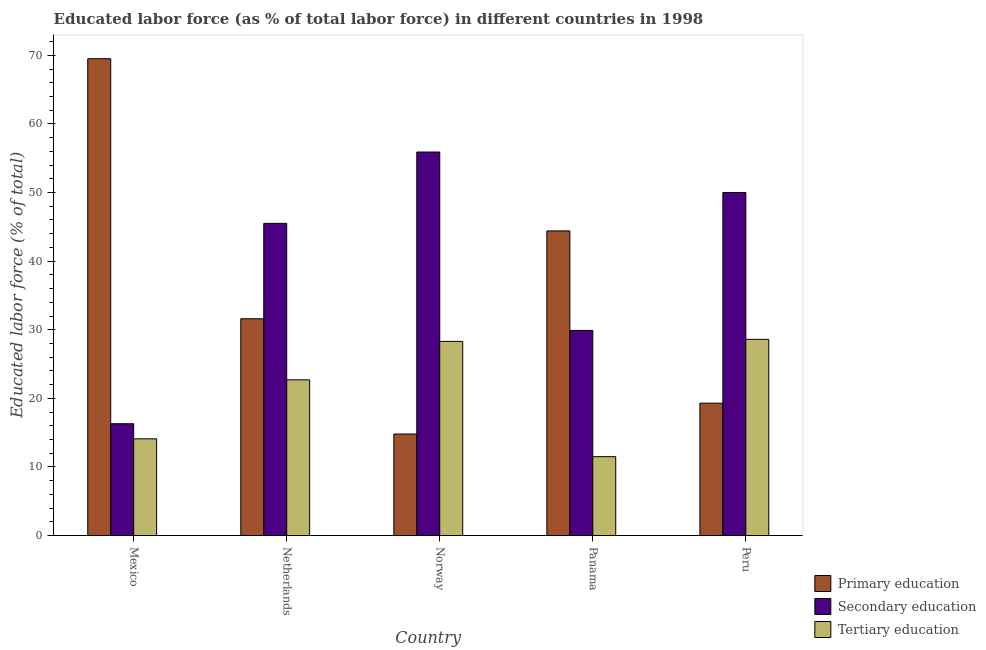How many different coloured bars are there?
Make the answer very short. 3. How many groups of bars are there?
Make the answer very short. 5. Are the number of bars per tick equal to the number of legend labels?
Your answer should be compact. Yes. What is the label of the 5th group of bars from the left?
Ensure brevity in your answer.  Peru. What is the percentage of labor force who received secondary education in Norway?
Ensure brevity in your answer.  55.9. Across all countries, what is the maximum percentage of labor force who received tertiary education?
Ensure brevity in your answer.  28.6. Across all countries, what is the minimum percentage of labor force who received primary education?
Give a very brief answer. 14.8. In which country was the percentage of labor force who received primary education minimum?
Keep it short and to the point. Norway. What is the total percentage of labor force who received tertiary education in the graph?
Give a very brief answer. 105.2. What is the difference between the percentage of labor force who received secondary education in Norway and that in Panama?
Make the answer very short. 26. What is the difference between the percentage of labor force who received secondary education in Peru and the percentage of labor force who received tertiary education in Netherlands?
Provide a short and direct response. 27.3. What is the average percentage of labor force who received secondary education per country?
Provide a succinct answer. 39.52. What is the difference between the percentage of labor force who received primary education and percentage of labor force who received tertiary education in Panama?
Keep it short and to the point. 32.9. In how many countries, is the percentage of labor force who received tertiary education greater than 20 %?
Your response must be concise. 3. What is the ratio of the percentage of labor force who received primary education in Norway to that in Peru?
Your answer should be very brief. 0.77. Is the difference between the percentage of labor force who received primary education in Norway and Peru greater than the difference between the percentage of labor force who received tertiary education in Norway and Peru?
Provide a short and direct response. No. What is the difference between the highest and the second highest percentage of labor force who received primary education?
Offer a terse response. 25.1. What is the difference between the highest and the lowest percentage of labor force who received secondary education?
Offer a terse response. 39.6. In how many countries, is the percentage of labor force who received tertiary education greater than the average percentage of labor force who received tertiary education taken over all countries?
Offer a terse response. 3. What does the 3rd bar from the left in Netherlands represents?
Offer a terse response. Tertiary education. What does the 3rd bar from the right in Norway represents?
Make the answer very short. Primary education. How many bars are there?
Your answer should be compact. 15. How many countries are there in the graph?
Your answer should be very brief. 5. What is the difference between two consecutive major ticks on the Y-axis?
Provide a short and direct response. 10. Does the graph contain grids?
Offer a terse response. No. Where does the legend appear in the graph?
Offer a terse response. Bottom right. What is the title of the graph?
Your answer should be very brief. Educated labor force (as % of total labor force) in different countries in 1998. Does "Food" appear as one of the legend labels in the graph?
Offer a very short reply. No. What is the label or title of the Y-axis?
Your answer should be compact. Educated labor force (% of total). What is the Educated labor force (% of total) in Primary education in Mexico?
Keep it short and to the point. 69.5. What is the Educated labor force (% of total) in Secondary education in Mexico?
Give a very brief answer. 16.3. What is the Educated labor force (% of total) of Tertiary education in Mexico?
Give a very brief answer. 14.1. What is the Educated labor force (% of total) in Primary education in Netherlands?
Your response must be concise. 31.6. What is the Educated labor force (% of total) in Secondary education in Netherlands?
Ensure brevity in your answer.  45.5. What is the Educated labor force (% of total) in Tertiary education in Netherlands?
Keep it short and to the point. 22.7. What is the Educated labor force (% of total) of Primary education in Norway?
Your answer should be very brief. 14.8. What is the Educated labor force (% of total) of Secondary education in Norway?
Your response must be concise. 55.9. What is the Educated labor force (% of total) of Tertiary education in Norway?
Make the answer very short. 28.3. What is the Educated labor force (% of total) in Primary education in Panama?
Your answer should be very brief. 44.4. What is the Educated labor force (% of total) of Secondary education in Panama?
Offer a terse response. 29.9. What is the Educated labor force (% of total) in Primary education in Peru?
Your answer should be very brief. 19.3. What is the Educated labor force (% of total) in Tertiary education in Peru?
Give a very brief answer. 28.6. Across all countries, what is the maximum Educated labor force (% of total) of Primary education?
Offer a very short reply. 69.5. Across all countries, what is the maximum Educated labor force (% of total) in Secondary education?
Offer a terse response. 55.9. Across all countries, what is the maximum Educated labor force (% of total) in Tertiary education?
Give a very brief answer. 28.6. Across all countries, what is the minimum Educated labor force (% of total) of Primary education?
Keep it short and to the point. 14.8. Across all countries, what is the minimum Educated labor force (% of total) of Secondary education?
Make the answer very short. 16.3. What is the total Educated labor force (% of total) of Primary education in the graph?
Provide a short and direct response. 179.6. What is the total Educated labor force (% of total) in Secondary education in the graph?
Give a very brief answer. 197.6. What is the total Educated labor force (% of total) of Tertiary education in the graph?
Provide a short and direct response. 105.2. What is the difference between the Educated labor force (% of total) of Primary education in Mexico and that in Netherlands?
Provide a succinct answer. 37.9. What is the difference between the Educated labor force (% of total) in Secondary education in Mexico and that in Netherlands?
Offer a very short reply. -29.2. What is the difference between the Educated labor force (% of total) of Tertiary education in Mexico and that in Netherlands?
Provide a succinct answer. -8.6. What is the difference between the Educated labor force (% of total) in Primary education in Mexico and that in Norway?
Provide a short and direct response. 54.7. What is the difference between the Educated labor force (% of total) in Secondary education in Mexico and that in Norway?
Provide a succinct answer. -39.6. What is the difference between the Educated labor force (% of total) in Tertiary education in Mexico and that in Norway?
Provide a succinct answer. -14.2. What is the difference between the Educated labor force (% of total) of Primary education in Mexico and that in Panama?
Keep it short and to the point. 25.1. What is the difference between the Educated labor force (% of total) in Tertiary education in Mexico and that in Panama?
Offer a terse response. 2.6. What is the difference between the Educated labor force (% of total) of Primary education in Mexico and that in Peru?
Your answer should be very brief. 50.2. What is the difference between the Educated labor force (% of total) in Secondary education in Mexico and that in Peru?
Make the answer very short. -33.7. What is the difference between the Educated labor force (% of total) of Tertiary education in Mexico and that in Peru?
Provide a succinct answer. -14.5. What is the difference between the Educated labor force (% of total) of Primary education in Netherlands and that in Norway?
Provide a short and direct response. 16.8. What is the difference between the Educated labor force (% of total) of Secondary education in Netherlands and that in Norway?
Your answer should be very brief. -10.4. What is the difference between the Educated labor force (% of total) in Secondary education in Netherlands and that in Panama?
Provide a succinct answer. 15.6. What is the difference between the Educated labor force (% of total) in Primary education in Netherlands and that in Peru?
Your answer should be very brief. 12.3. What is the difference between the Educated labor force (% of total) in Secondary education in Netherlands and that in Peru?
Keep it short and to the point. -4.5. What is the difference between the Educated labor force (% of total) of Tertiary education in Netherlands and that in Peru?
Offer a terse response. -5.9. What is the difference between the Educated labor force (% of total) in Primary education in Norway and that in Panama?
Provide a succinct answer. -29.6. What is the difference between the Educated labor force (% of total) of Secondary education in Norway and that in Panama?
Your response must be concise. 26. What is the difference between the Educated labor force (% of total) in Primary education in Panama and that in Peru?
Offer a very short reply. 25.1. What is the difference between the Educated labor force (% of total) of Secondary education in Panama and that in Peru?
Make the answer very short. -20.1. What is the difference between the Educated labor force (% of total) in Tertiary education in Panama and that in Peru?
Give a very brief answer. -17.1. What is the difference between the Educated labor force (% of total) in Primary education in Mexico and the Educated labor force (% of total) in Secondary education in Netherlands?
Ensure brevity in your answer.  24. What is the difference between the Educated labor force (% of total) of Primary education in Mexico and the Educated labor force (% of total) of Tertiary education in Netherlands?
Ensure brevity in your answer.  46.8. What is the difference between the Educated labor force (% of total) of Primary education in Mexico and the Educated labor force (% of total) of Tertiary education in Norway?
Your answer should be compact. 41.2. What is the difference between the Educated labor force (% of total) in Primary education in Mexico and the Educated labor force (% of total) in Secondary education in Panama?
Your response must be concise. 39.6. What is the difference between the Educated labor force (% of total) of Primary education in Mexico and the Educated labor force (% of total) of Tertiary education in Panama?
Give a very brief answer. 58. What is the difference between the Educated labor force (% of total) in Primary education in Mexico and the Educated labor force (% of total) in Secondary education in Peru?
Your answer should be very brief. 19.5. What is the difference between the Educated labor force (% of total) in Primary education in Mexico and the Educated labor force (% of total) in Tertiary education in Peru?
Your response must be concise. 40.9. What is the difference between the Educated labor force (% of total) in Primary education in Netherlands and the Educated labor force (% of total) in Secondary education in Norway?
Ensure brevity in your answer.  -24.3. What is the difference between the Educated labor force (% of total) in Secondary education in Netherlands and the Educated labor force (% of total) in Tertiary education in Norway?
Provide a short and direct response. 17.2. What is the difference between the Educated labor force (% of total) of Primary education in Netherlands and the Educated labor force (% of total) of Secondary education in Panama?
Your answer should be very brief. 1.7. What is the difference between the Educated labor force (% of total) in Primary education in Netherlands and the Educated labor force (% of total) in Tertiary education in Panama?
Your response must be concise. 20.1. What is the difference between the Educated labor force (% of total) of Secondary education in Netherlands and the Educated labor force (% of total) of Tertiary education in Panama?
Your response must be concise. 34. What is the difference between the Educated labor force (% of total) in Primary education in Netherlands and the Educated labor force (% of total) in Secondary education in Peru?
Offer a terse response. -18.4. What is the difference between the Educated labor force (% of total) in Secondary education in Netherlands and the Educated labor force (% of total) in Tertiary education in Peru?
Offer a terse response. 16.9. What is the difference between the Educated labor force (% of total) of Primary education in Norway and the Educated labor force (% of total) of Secondary education in Panama?
Keep it short and to the point. -15.1. What is the difference between the Educated labor force (% of total) in Secondary education in Norway and the Educated labor force (% of total) in Tertiary education in Panama?
Offer a terse response. 44.4. What is the difference between the Educated labor force (% of total) of Primary education in Norway and the Educated labor force (% of total) of Secondary education in Peru?
Ensure brevity in your answer.  -35.2. What is the difference between the Educated labor force (% of total) in Secondary education in Norway and the Educated labor force (% of total) in Tertiary education in Peru?
Ensure brevity in your answer.  27.3. What is the difference between the Educated labor force (% of total) in Primary education in Panama and the Educated labor force (% of total) in Secondary education in Peru?
Offer a terse response. -5.6. What is the difference between the Educated labor force (% of total) in Primary education in Panama and the Educated labor force (% of total) in Tertiary education in Peru?
Your answer should be compact. 15.8. What is the difference between the Educated labor force (% of total) in Secondary education in Panama and the Educated labor force (% of total) in Tertiary education in Peru?
Make the answer very short. 1.3. What is the average Educated labor force (% of total) of Primary education per country?
Provide a succinct answer. 35.92. What is the average Educated labor force (% of total) in Secondary education per country?
Ensure brevity in your answer.  39.52. What is the average Educated labor force (% of total) of Tertiary education per country?
Provide a short and direct response. 21.04. What is the difference between the Educated labor force (% of total) of Primary education and Educated labor force (% of total) of Secondary education in Mexico?
Offer a very short reply. 53.2. What is the difference between the Educated labor force (% of total) in Primary education and Educated labor force (% of total) in Tertiary education in Mexico?
Your response must be concise. 55.4. What is the difference between the Educated labor force (% of total) in Secondary education and Educated labor force (% of total) in Tertiary education in Netherlands?
Provide a short and direct response. 22.8. What is the difference between the Educated labor force (% of total) in Primary education and Educated labor force (% of total) in Secondary education in Norway?
Offer a terse response. -41.1. What is the difference between the Educated labor force (% of total) of Secondary education and Educated labor force (% of total) of Tertiary education in Norway?
Give a very brief answer. 27.6. What is the difference between the Educated labor force (% of total) in Primary education and Educated labor force (% of total) in Secondary education in Panama?
Offer a very short reply. 14.5. What is the difference between the Educated labor force (% of total) of Primary education and Educated labor force (% of total) of Tertiary education in Panama?
Your answer should be very brief. 32.9. What is the difference between the Educated labor force (% of total) of Secondary education and Educated labor force (% of total) of Tertiary education in Panama?
Your answer should be compact. 18.4. What is the difference between the Educated labor force (% of total) of Primary education and Educated labor force (% of total) of Secondary education in Peru?
Make the answer very short. -30.7. What is the difference between the Educated labor force (% of total) of Primary education and Educated labor force (% of total) of Tertiary education in Peru?
Give a very brief answer. -9.3. What is the difference between the Educated labor force (% of total) in Secondary education and Educated labor force (% of total) in Tertiary education in Peru?
Your answer should be very brief. 21.4. What is the ratio of the Educated labor force (% of total) of Primary education in Mexico to that in Netherlands?
Offer a very short reply. 2.2. What is the ratio of the Educated labor force (% of total) of Secondary education in Mexico to that in Netherlands?
Offer a very short reply. 0.36. What is the ratio of the Educated labor force (% of total) in Tertiary education in Mexico to that in Netherlands?
Your response must be concise. 0.62. What is the ratio of the Educated labor force (% of total) of Primary education in Mexico to that in Norway?
Offer a very short reply. 4.7. What is the ratio of the Educated labor force (% of total) of Secondary education in Mexico to that in Norway?
Your response must be concise. 0.29. What is the ratio of the Educated labor force (% of total) in Tertiary education in Mexico to that in Norway?
Offer a very short reply. 0.5. What is the ratio of the Educated labor force (% of total) of Primary education in Mexico to that in Panama?
Ensure brevity in your answer.  1.57. What is the ratio of the Educated labor force (% of total) of Secondary education in Mexico to that in Panama?
Offer a terse response. 0.55. What is the ratio of the Educated labor force (% of total) of Tertiary education in Mexico to that in Panama?
Provide a short and direct response. 1.23. What is the ratio of the Educated labor force (% of total) in Primary education in Mexico to that in Peru?
Provide a short and direct response. 3.6. What is the ratio of the Educated labor force (% of total) in Secondary education in Mexico to that in Peru?
Keep it short and to the point. 0.33. What is the ratio of the Educated labor force (% of total) in Tertiary education in Mexico to that in Peru?
Your answer should be compact. 0.49. What is the ratio of the Educated labor force (% of total) in Primary education in Netherlands to that in Norway?
Make the answer very short. 2.14. What is the ratio of the Educated labor force (% of total) of Secondary education in Netherlands to that in Norway?
Make the answer very short. 0.81. What is the ratio of the Educated labor force (% of total) in Tertiary education in Netherlands to that in Norway?
Keep it short and to the point. 0.8. What is the ratio of the Educated labor force (% of total) in Primary education in Netherlands to that in Panama?
Ensure brevity in your answer.  0.71. What is the ratio of the Educated labor force (% of total) of Secondary education in Netherlands to that in Panama?
Your response must be concise. 1.52. What is the ratio of the Educated labor force (% of total) in Tertiary education in Netherlands to that in Panama?
Offer a very short reply. 1.97. What is the ratio of the Educated labor force (% of total) of Primary education in Netherlands to that in Peru?
Make the answer very short. 1.64. What is the ratio of the Educated labor force (% of total) of Secondary education in Netherlands to that in Peru?
Offer a terse response. 0.91. What is the ratio of the Educated labor force (% of total) of Tertiary education in Netherlands to that in Peru?
Your response must be concise. 0.79. What is the ratio of the Educated labor force (% of total) of Primary education in Norway to that in Panama?
Your answer should be very brief. 0.33. What is the ratio of the Educated labor force (% of total) in Secondary education in Norway to that in Panama?
Your response must be concise. 1.87. What is the ratio of the Educated labor force (% of total) in Tertiary education in Norway to that in Panama?
Ensure brevity in your answer.  2.46. What is the ratio of the Educated labor force (% of total) of Primary education in Norway to that in Peru?
Your response must be concise. 0.77. What is the ratio of the Educated labor force (% of total) of Secondary education in Norway to that in Peru?
Offer a terse response. 1.12. What is the ratio of the Educated labor force (% of total) in Tertiary education in Norway to that in Peru?
Provide a succinct answer. 0.99. What is the ratio of the Educated labor force (% of total) in Primary education in Panama to that in Peru?
Your answer should be compact. 2.3. What is the ratio of the Educated labor force (% of total) in Secondary education in Panama to that in Peru?
Provide a short and direct response. 0.6. What is the ratio of the Educated labor force (% of total) in Tertiary education in Panama to that in Peru?
Your response must be concise. 0.4. What is the difference between the highest and the second highest Educated labor force (% of total) in Primary education?
Ensure brevity in your answer.  25.1. What is the difference between the highest and the second highest Educated labor force (% of total) in Secondary education?
Provide a succinct answer. 5.9. What is the difference between the highest and the lowest Educated labor force (% of total) of Primary education?
Your answer should be very brief. 54.7. What is the difference between the highest and the lowest Educated labor force (% of total) in Secondary education?
Offer a terse response. 39.6. 